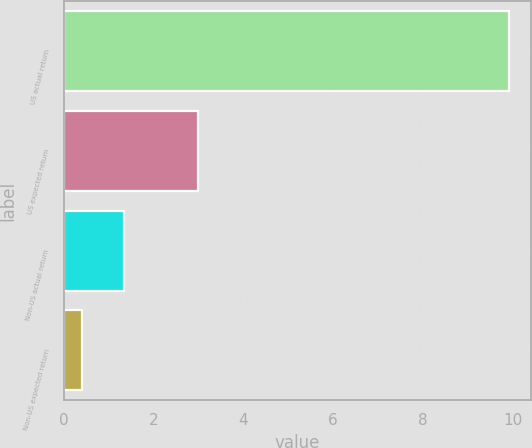Convert chart. <chart><loc_0><loc_0><loc_500><loc_500><bar_chart><fcel>US actual return<fcel>US expected return<fcel>Non-US actual return<fcel>Non-US expected return<nl><fcel>9.9<fcel>3<fcel>1.35<fcel>0.4<nl></chart> 